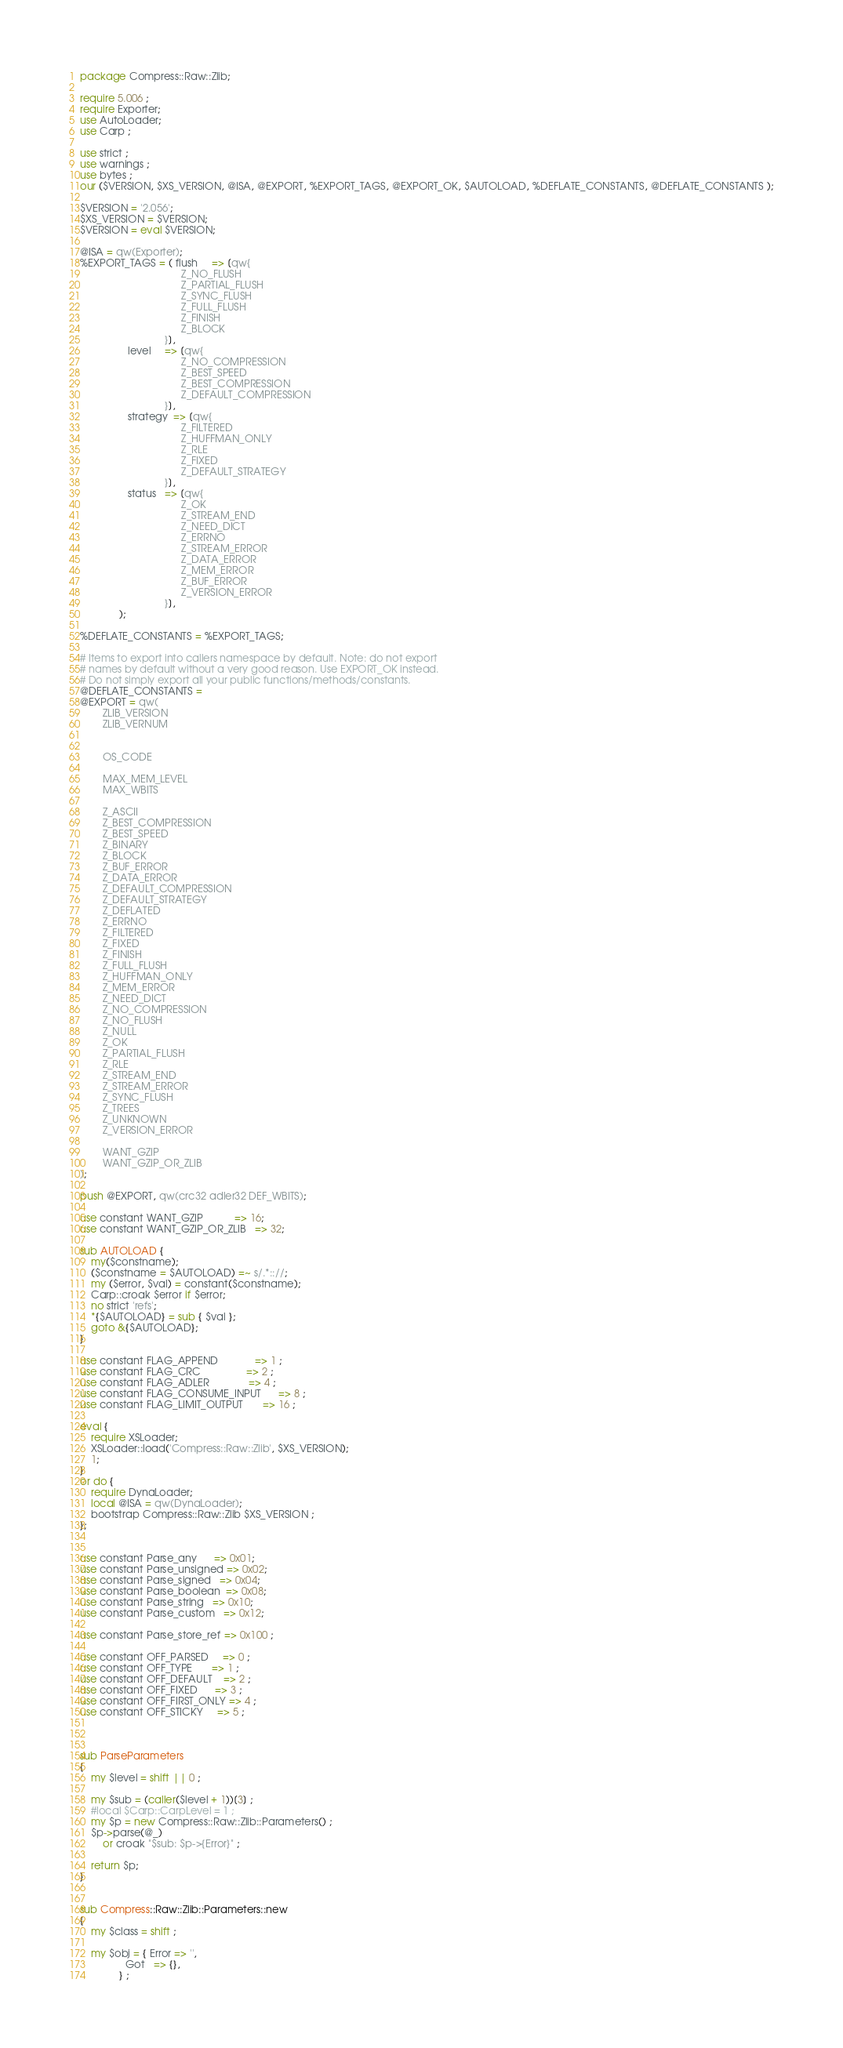<code> <loc_0><loc_0><loc_500><loc_500><_Perl_>
package Compress::Raw::Zlib;

require 5.006 ;
require Exporter;
use AutoLoader;
use Carp ;

use strict ;
use warnings ;
use bytes ;
our ($VERSION, $XS_VERSION, @ISA, @EXPORT, %EXPORT_TAGS, @EXPORT_OK, $AUTOLOAD, %DEFLATE_CONSTANTS, @DEFLATE_CONSTANTS );

$VERSION = '2.056';
$XS_VERSION = $VERSION; 
$VERSION = eval $VERSION;

@ISA = qw(Exporter);
%EXPORT_TAGS = ( flush     => [qw{  
                                    Z_NO_FLUSH
                                    Z_PARTIAL_FLUSH
                                    Z_SYNC_FLUSH
                                    Z_FULL_FLUSH
                                    Z_FINISH
                                    Z_BLOCK
                              }],
                 level     => [qw{  
                                    Z_NO_COMPRESSION
                                    Z_BEST_SPEED
                                    Z_BEST_COMPRESSION
                                    Z_DEFAULT_COMPRESSION
                              }],
                 strategy  => [qw{  
                                    Z_FILTERED
                                    Z_HUFFMAN_ONLY
                                    Z_RLE
                                    Z_FIXED
                                    Z_DEFAULT_STRATEGY
                              }],
                 status   => [qw{  
                                    Z_OK
                                    Z_STREAM_END
                                    Z_NEED_DICT
                                    Z_ERRNO
                                    Z_STREAM_ERROR
                                    Z_DATA_ERROR  
                                    Z_MEM_ERROR   
                                    Z_BUF_ERROR 
                                    Z_VERSION_ERROR 
                              }],                              
              );

%DEFLATE_CONSTANTS = %EXPORT_TAGS;

# Items to export into callers namespace by default. Note: do not export
# names by default without a very good reason. Use EXPORT_OK instead.
# Do not simply export all your public functions/methods/constants.
@DEFLATE_CONSTANTS = 
@EXPORT = qw(
        ZLIB_VERSION
        ZLIB_VERNUM

        
        OS_CODE

        MAX_MEM_LEVEL
        MAX_WBITS

        Z_ASCII
        Z_BEST_COMPRESSION
        Z_BEST_SPEED
        Z_BINARY
        Z_BLOCK
        Z_BUF_ERROR
        Z_DATA_ERROR
        Z_DEFAULT_COMPRESSION
        Z_DEFAULT_STRATEGY
        Z_DEFLATED
        Z_ERRNO
        Z_FILTERED
        Z_FIXED
        Z_FINISH
        Z_FULL_FLUSH
        Z_HUFFMAN_ONLY
        Z_MEM_ERROR
        Z_NEED_DICT
        Z_NO_COMPRESSION
        Z_NO_FLUSH
        Z_NULL
        Z_OK
        Z_PARTIAL_FLUSH
        Z_RLE
        Z_STREAM_END
        Z_STREAM_ERROR
        Z_SYNC_FLUSH
        Z_TREES
        Z_UNKNOWN
        Z_VERSION_ERROR

        WANT_GZIP
        WANT_GZIP_OR_ZLIB
);

push @EXPORT, qw(crc32 adler32 DEF_WBITS);

use constant WANT_GZIP           => 16;
use constant WANT_GZIP_OR_ZLIB   => 32;

sub AUTOLOAD {
    my($constname);
    ($constname = $AUTOLOAD) =~ s/.*:://;
    my ($error, $val) = constant($constname);
    Carp::croak $error if $error;
    no strict 'refs';
    *{$AUTOLOAD} = sub { $val };
    goto &{$AUTOLOAD};
}

use constant FLAG_APPEND             => 1 ;
use constant FLAG_CRC                => 2 ;
use constant FLAG_ADLER              => 4 ;
use constant FLAG_CONSUME_INPUT      => 8 ;
use constant FLAG_LIMIT_OUTPUT       => 16 ;

eval {
    require XSLoader;
    XSLoader::load('Compress::Raw::Zlib', $XS_VERSION);
    1;
} 
or do {
    require DynaLoader;
    local @ISA = qw(DynaLoader);
    bootstrap Compress::Raw::Zlib $XS_VERSION ; 
};
 

use constant Parse_any      => 0x01;
use constant Parse_unsigned => 0x02;
use constant Parse_signed   => 0x04;
use constant Parse_boolean  => 0x08;
use constant Parse_string   => 0x10;
use constant Parse_custom   => 0x12;

use constant Parse_store_ref => 0x100 ;

use constant OFF_PARSED     => 0 ;
use constant OFF_TYPE       => 1 ;
use constant OFF_DEFAULT    => 2 ;
use constant OFF_FIXED      => 3 ;
use constant OFF_FIRST_ONLY => 4 ;
use constant OFF_STICKY     => 5 ;



sub ParseParameters
{
    my $level = shift || 0 ; 

    my $sub = (caller($level + 1))[3] ;
    #local $Carp::CarpLevel = 1 ;
    my $p = new Compress::Raw::Zlib::Parameters() ;
    $p->parse(@_)
        or croak "$sub: $p->{Error}" ;

    return $p;
}


sub Compress::Raw::Zlib::Parameters::new
{
    my $class = shift ;

    my $obj = { Error => '',
                Got   => {},
              } ;
</code> 